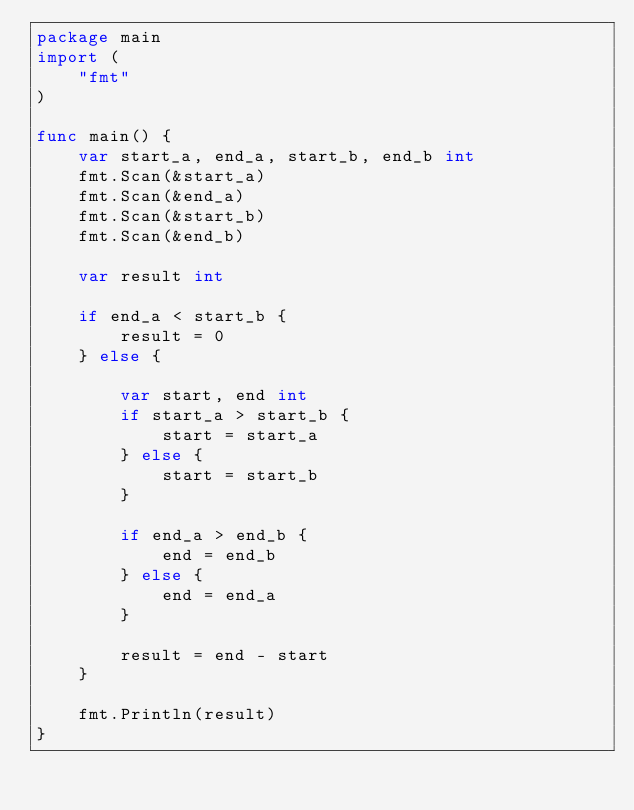Convert code to text. <code><loc_0><loc_0><loc_500><loc_500><_Go_>package main
import (
    "fmt"
)

func main() {
    var start_a, end_a, start_b, end_b int
    fmt.Scan(&start_a)
    fmt.Scan(&end_a)
    fmt.Scan(&start_b)
    fmt.Scan(&end_b)

    var result int

    if end_a < start_b {
        result = 0
    } else {

        var start, end int
        if start_a > start_b {
            start = start_a
        } else {
            start = start_b
        }

        if end_a > end_b {
            end = end_b
        } else {
            end = end_a
        }

        result = end - start
    }

    fmt.Println(result)
}
</code> 